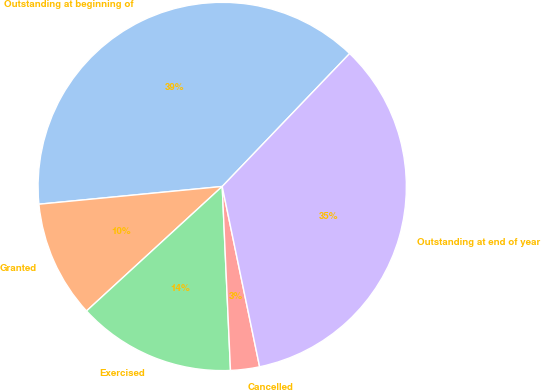Convert chart to OTSL. <chart><loc_0><loc_0><loc_500><loc_500><pie_chart><fcel>Outstanding at beginning of<fcel>Granted<fcel>Exercised<fcel>Cancelled<fcel>Outstanding at end of year<nl><fcel>38.7%<fcel>10.28%<fcel>13.9%<fcel>2.54%<fcel>34.58%<nl></chart> 